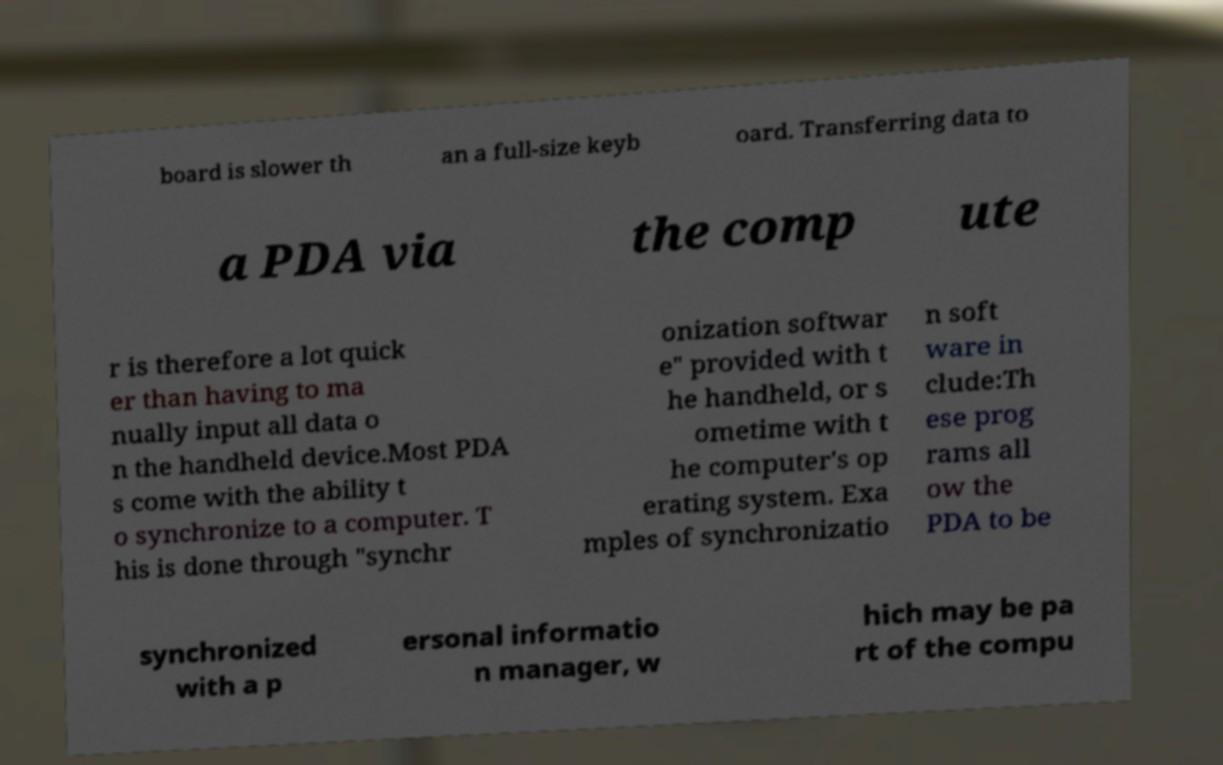What messages or text are displayed in this image? I need them in a readable, typed format. board is slower th an a full-size keyb oard. Transferring data to a PDA via the comp ute r is therefore a lot quick er than having to ma nually input all data o n the handheld device.Most PDA s come with the ability t o synchronize to a computer. T his is done through "synchr onization softwar e" provided with t he handheld, or s ometime with t he computer's op erating system. Exa mples of synchronizatio n soft ware in clude:Th ese prog rams all ow the PDA to be synchronized with a p ersonal informatio n manager, w hich may be pa rt of the compu 